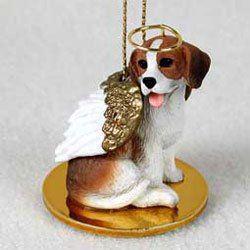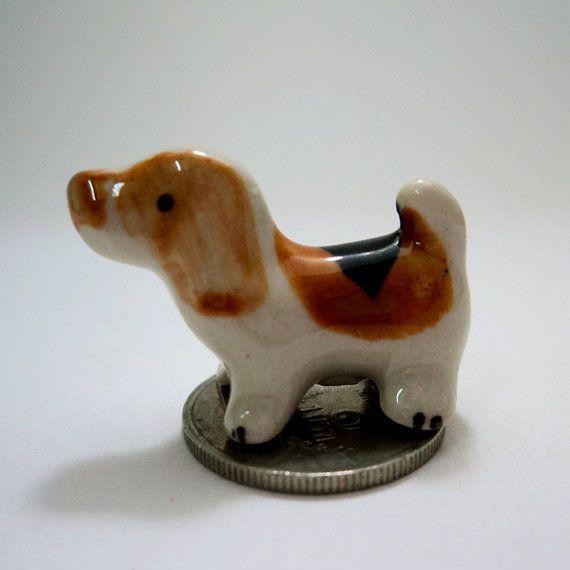The first image is the image on the left, the second image is the image on the right. Examine the images to the left and right. Is the description "At least one of the puppies is real and is sitting down." accurate? Answer yes or no. No. 